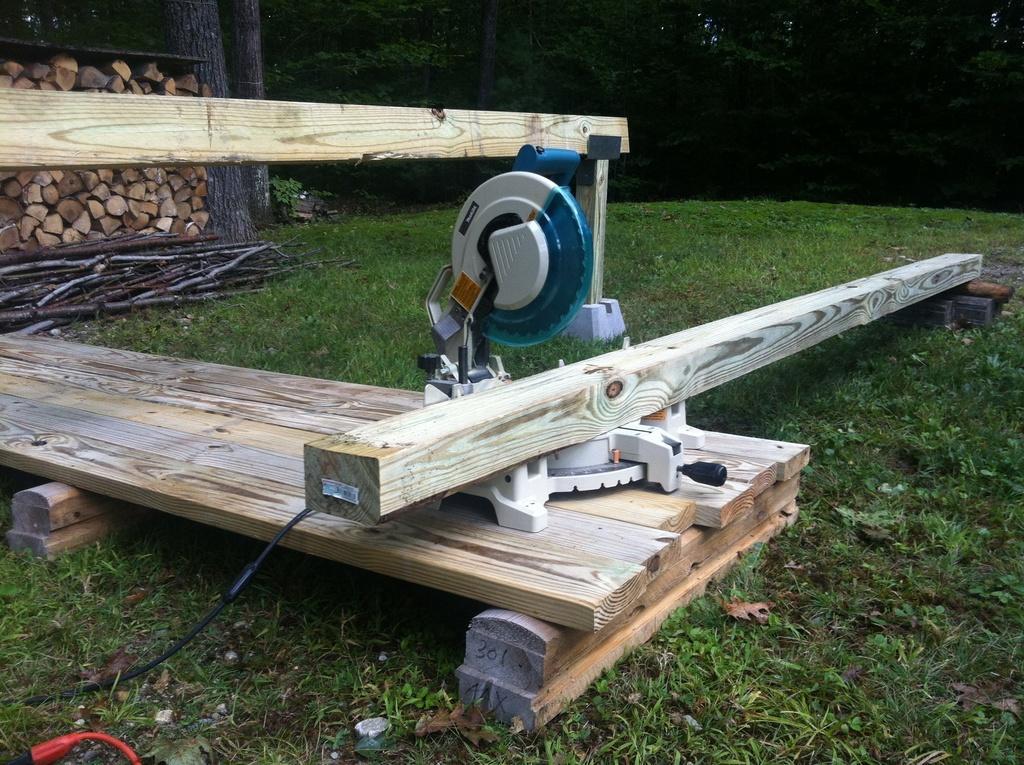Please provide a concise description of this image. In this image I can see a wooden surface which is brown, cream and white in color and a machine which is blue and grey in color on the wooden surface. I can see a wooden log on it. In the background I can see few wooden logs which are brown in color, some grass on the ground and few trees which are green in color. 